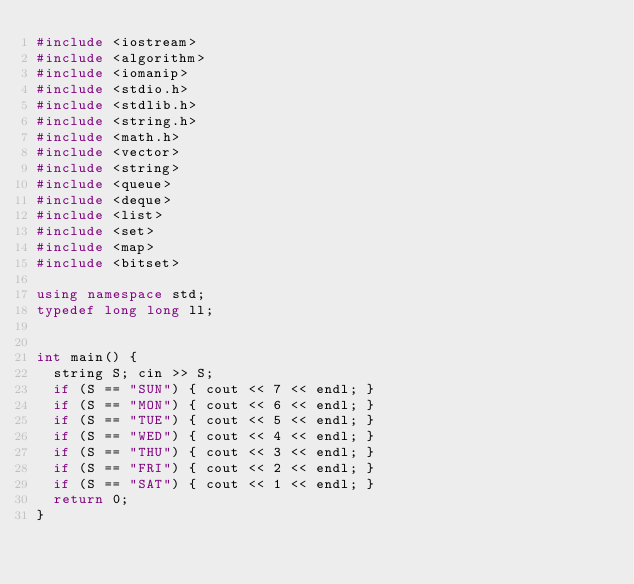<code> <loc_0><loc_0><loc_500><loc_500><_C++_>#include <iostream>
#include <algorithm>
#include <iomanip>
#include <stdio.h>
#include <stdlib.h>
#include <string.h>
#include <math.h>
#include <vector>
#include <string>
#include <queue>
#include <deque>
#include <list>
#include <set>
#include <map>
#include <bitset>

using namespace std;
typedef long long ll;


int main() {
	string S; cin >> S;
	if (S == "SUN") { cout << 7 << endl; }
	if (S == "MON") { cout << 6 << endl; }
	if (S == "TUE") { cout << 5 << endl; }
	if (S == "WED") { cout << 4 << endl; }
	if (S == "THU") { cout << 3 << endl; }
	if (S == "FRI") { cout << 2 << endl; }
	if (S == "SAT") { cout << 1 << endl; }
	return 0;
}</code> 